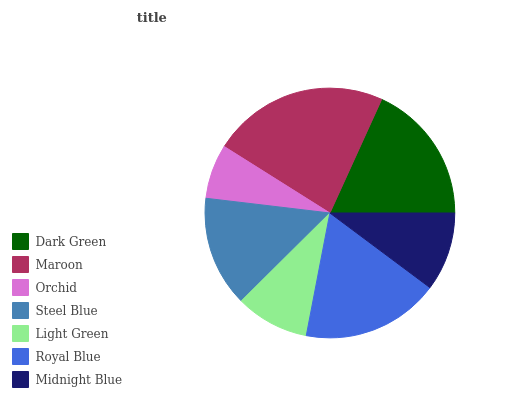Is Orchid the minimum?
Answer yes or no. Yes. Is Maroon the maximum?
Answer yes or no. Yes. Is Maroon the minimum?
Answer yes or no. No. Is Orchid the maximum?
Answer yes or no. No. Is Maroon greater than Orchid?
Answer yes or no. Yes. Is Orchid less than Maroon?
Answer yes or no. Yes. Is Orchid greater than Maroon?
Answer yes or no. No. Is Maroon less than Orchid?
Answer yes or no. No. Is Steel Blue the high median?
Answer yes or no. Yes. Is Steel Blue the low median?
Answer yes or no. Yes. Is Orchid the high median?
Answer yes or no. No. Is Dark Green the low median?
Answer yes or no. No. 